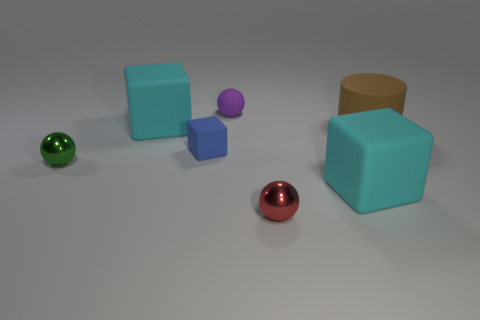Add 3 green matte spheres. How many objects exist? 10 Subtract all cylinders. How many objects are left? 6 Add 4 tiny rubber balls. How many tiny rubber balls exist? 5 Subtract 1 green balls. How many objects are left? 6 Subtract all tiny purple rubber spheres. Subtract all matte balls. How many objects are left? 5 Add 2 blue rubber blocks. How many blue rubber blocks are left? 3 